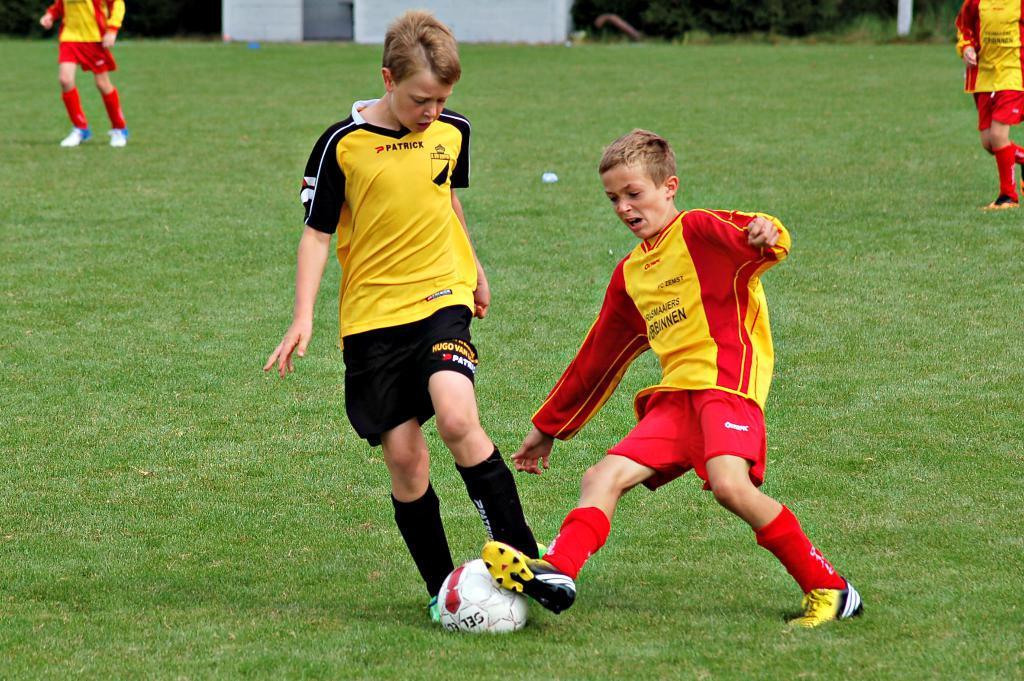In one or two sentences, can you explain what this image depicts? In this picture we can see two persons playing with the ball in the ground. This is the grass. 